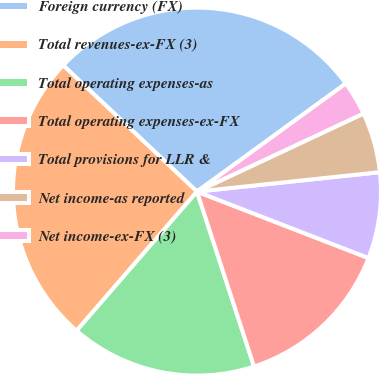<chart> <loc_0><loc_0><loc_500><loc_500><pie_chart><fcel>Foreign currency (FX)<fcel>Total revenues-ex-FX (3)<fcel>Total operating expenses-as<fcel>Total operating expenses-ex-FX<fcel>Total provisions for LLR &<fcel>Net income-as reported<fcel>Net income-ex-FX (3)<nl><fcel>27.96%<fcel>25.69%<fcel>16.37%<fcel>14.1%<fcel>7.57%<fcel>5.29%<fcel>3.02%<nl></chart> 